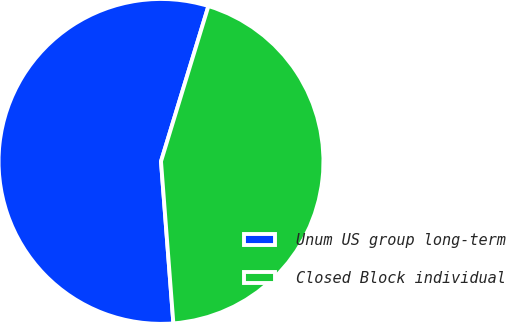Convert chart to OTSL. <chart><loc_0><loc_0><loc_500><loc_500><pie_chart><fcel>Unum US group long-term<fcel>Closed Block individual<nl><fcel>55.93%<fcel>44.07%<nl></chart> 